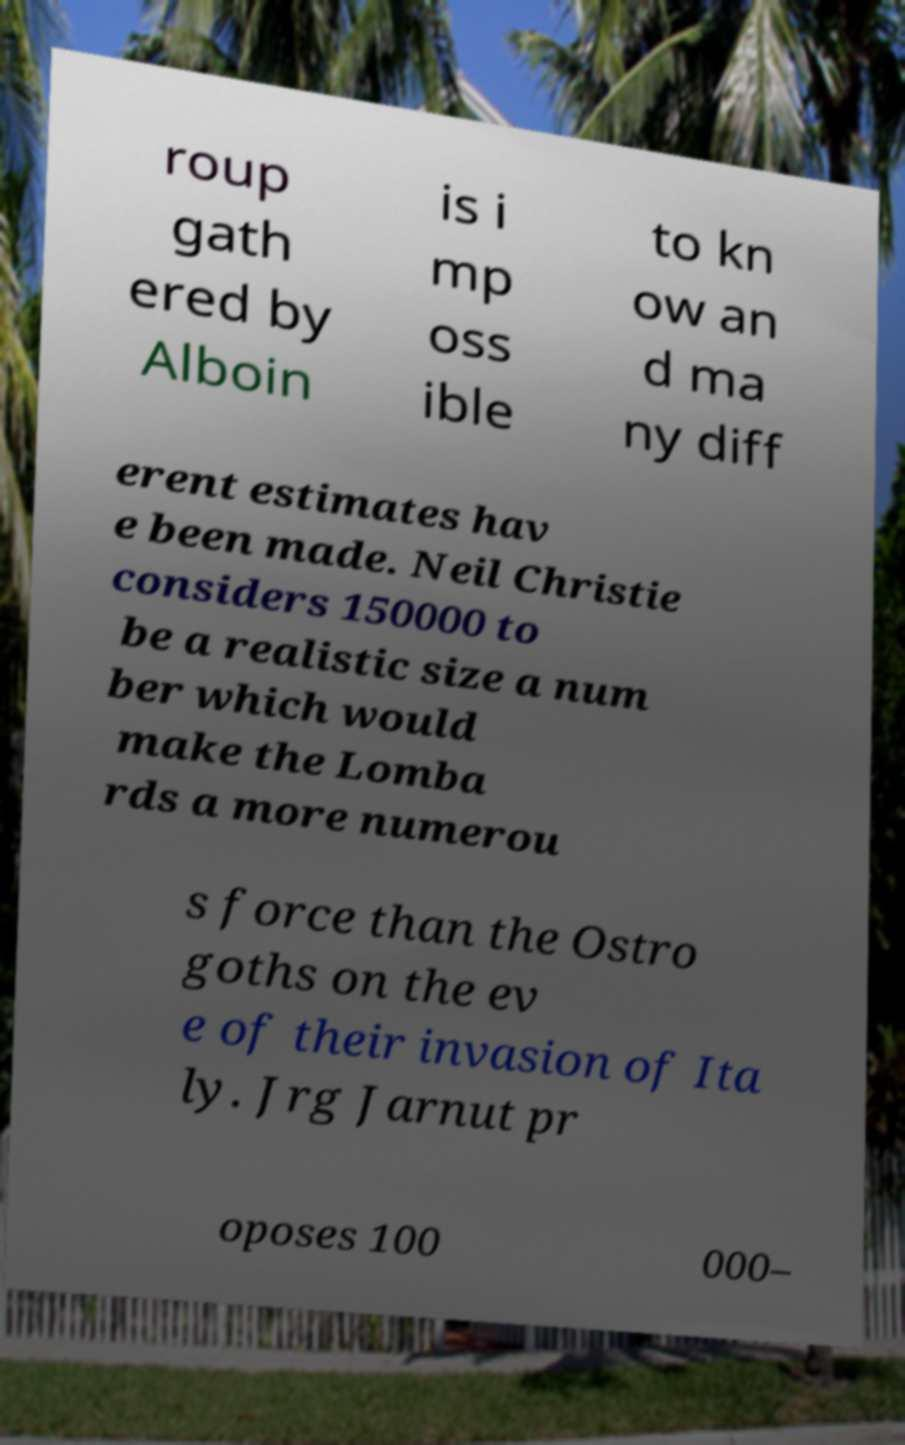For documentation purposes, I need the text within this image transcribed. Could you provide that? roup gath ered by Alboin is i mp oss ible to kn ow an d ma ny diff erent estimates hav e been made. Neil Christie considers 150000 to be a realistic size a num ber which would make the Lomba rds a more numerou s force than the Ostro goths on the ev e of their invasion of Ita ly. Jrg Jarnut pr oposes 100 000– 